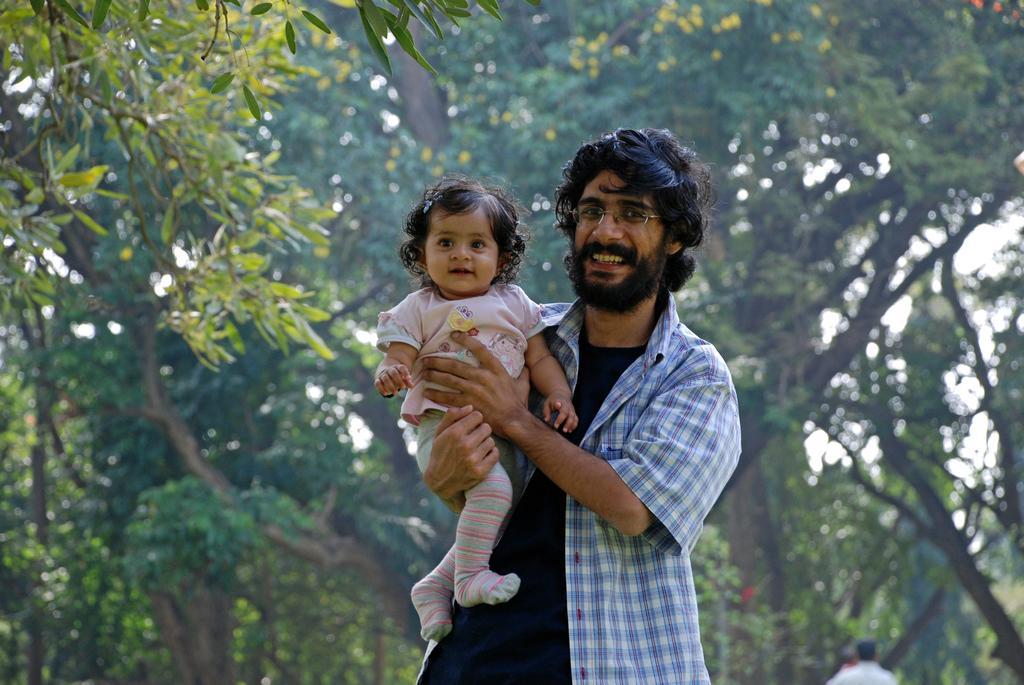In one or two sentences, can you explain what this image depicts? In this picture I can see there is a man standing here and he is holding a child in his hand and the baby is smiling and in the backdrop there are trees and there are two persons standing. 